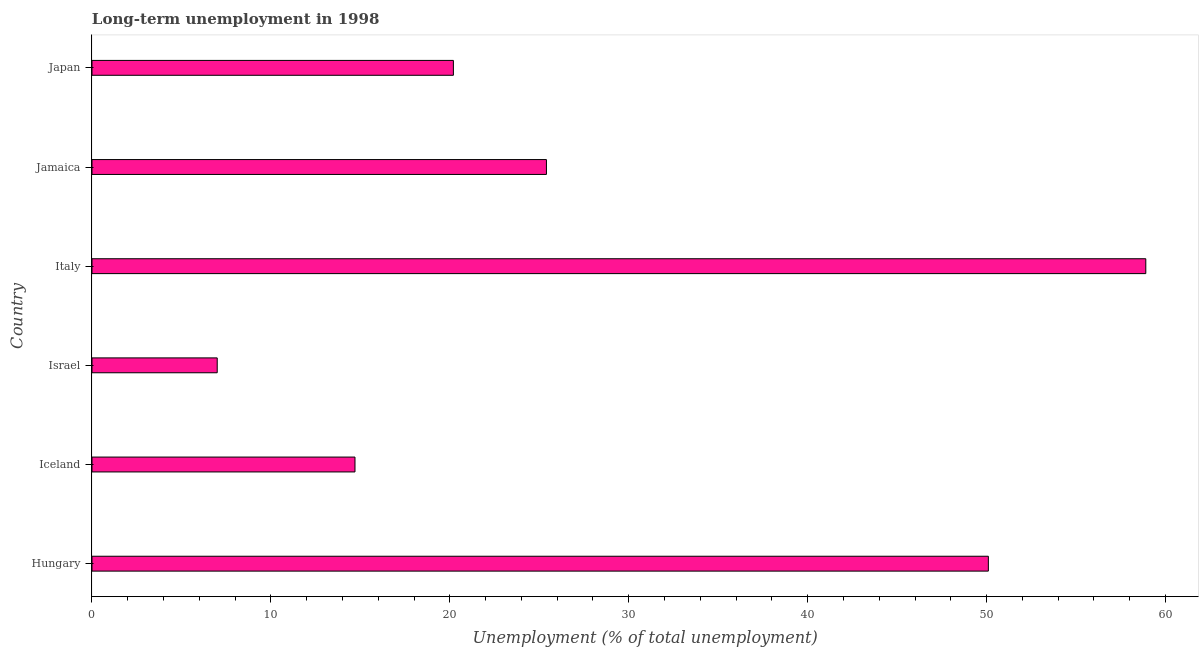Does the graph contain any zero values?
Offer a terse response. No. What is the title of the graph?
Provide a succinct answer. Long-term unemployment in 1998. What is the label or title of the X-axis?
Give a very brief answer. Unemployment (% of total unemployment). What is the label or title of the Y-axis?
Provide a short and direct response. Country. What is the long-term unemployment in Jamaica?
Your answer should be compact. 25.4. Across all countries, what is the maximum long-term unemployment?
Keep it short and to the point. 58.9. In which country was the long-term unemployment maximum?
Provide a succinct answer. Italy. In which country was the long-term unemployment minimum?
Your answer should be compact. Israel. What is the sum of the long-term unemployment?
Make the answer very short. 176.3. What is the average long-term unemployment per country?
Make the answer very short. 29.38. What is the median long-term unemployment?
Make the answer very short. 22.8. What is the ratio of the long-term unemployment in Iceland to that in Jamaica?
Your response must be concise. 0.58. Is the long-term unemployment in Israel less than that in Japan?
Your answer should be very brief. Yes. What is the difference between the highest and the second highest long-term unemployment?
Your answer should be compact. 8.8. Is the sum of the long-term unemployment in Iceland and Israel greater than the maximum long-term unemployment across all countries?
Your answer should be compact. No. What is the difference between the highest and the lowest long-term unemployment?
Your answer should be compact. 51.9. In how many countries, is the long-term unemployment greater than the average long-term unemployment taken over all countries?
Offer a very short reply. 2. Are all the bars in the graph horizontal?
Keep it short and to the point. Yes. How many countries are there in the graph?
Keep it short and to the point. 6. What is the difference between two consecutive major ticks on the X-axis?
Your response must be concise. 10. Are the values on the major ticks of X-axis written in scientific E-notation?
Provide a succinct answer. No. What is the Unemployment (% of total unemployment) in Hungary?
Provide a short and direct response. 50.1. What is the Unemployment (% of total unemployment) in Iceland?
Make the answer very short. 14.7. What is the Unemployment (% of total unemployment) of Israel?
Keep it short and to the point. 7. What is the Unemployment (% of total unemployment) of Italy?
Your answer should be compact. 58.9. What is the Unemployment (% of total unemployment) in Jamaica?
Ensure brevity in your answer.  25.4. What is the Unemployment (% of total unemployment) in Japan?
Provide a short and direct response. 20.2. What is the difference between the Unemployment (% of total unemployment) in Hungary and Iceland?
Your answer should be compact. 35.4. What is the difference between the Unemployment (% of total unemployment) in Hungary and Israel?
Your answer should be compact. 43.1. What is the difference between the Unemployment (% of total unemployment) in Hungary and Jamaica?
Make the answer very short. 24.7. What is the difference between the Unemployment (% of total unemployment) in Hungary and Japan?
Keep it short and to the point. 29.9. What is the difference between the Unemployment (% of total unemployment) in Iceland and Italy?
Provide a short and direct response. -44.2. What is the difference between the Unemployment (% of total unemployment) in Iceland and Japan?
Provide a succinct answer. -5.5. What is the difference between the Unemployment (% of total unemployment) in Israel and Italy?
Offer a very short reply. -51.9. What is the difference between the Unemployment (% of total unemployment) in Israel and Jamaica?
Make the answer very short. -18.4. What is the difference between the Unemployment (% of total unemployment) in Israel and Japan?
Keep it short and to the point. -13.2. What is the difference between the Unemployment (% of total unemployment) in Italy and Jamaica?
Keep it short and to the point. 33.5. What is the difference between the Unemployment (% of total unemployment) in Italy and Japan?
Offer a terse response. 38.7. What is the difference between the Unemployment (% of total unemployment) in Jamaica and Japan?
Make the answer very short. 5.2. What is the ratio of the Unemployment (% of total unemployment) in Hungary to that in Iceland?
Give a very brief answer. 3.41. What is the ratio of the Unemployment (% of total unemployment) in Hungary to that in Israel?
Your answer should be very brief. 7.16. What is the ratio of the Unemployment (% of total unemployment) in Hungary to that in Italy?
Provide a short and direct response. 0.85. What is the ratio of the Unemployment (% of total unemployment) in Hungary to that in Jamaica?
Offer a terse response. 1.97. What is the ratio of the Unemployment (% of total unemployment) in Hungary to that in Japan?
Keep it short and to the point. 2.48. What is the ratio of the Unemployment (% of total unemployment) in Iceland to that in Italy?
Your answer should be very brief. 0.25. What is the ratio of the Unemployment (% of total unemployment) in Iceland to that in Jamaica?
Offer a terse response. 0.58. What is the ratio of the Unemployment (% of total unemployment) in Iceland to that in Japan?
Offer a very short reply. 0.73. What is the ratio of the Unemployment (% of total unemployment) in Israel to that in Italy?
Offer a very short reply. 0.12. What is the ratio of the Unemployment (% of total unemployment) in Israel to that in Jamaica?
Give a very brief answer. 0.28. What is the ratio of the Unemployment (% of total unemployment) in Israel to that in Japan?
Give a very brief answer. 0.35. What is the ratio of the Unemployment (% of total unemployment) in Italy to that in Jamaica?
Offer a terse response. 2.32. What is the ratio of the Unemployment (% of total unemployment) in Italy to that in Japan?
Give a very brief answer. 2.92. What is the ratio of the Unemployment (% of total unemployment) in Jamaica to that in Japan?
Offer a very short reply. 1.26. 